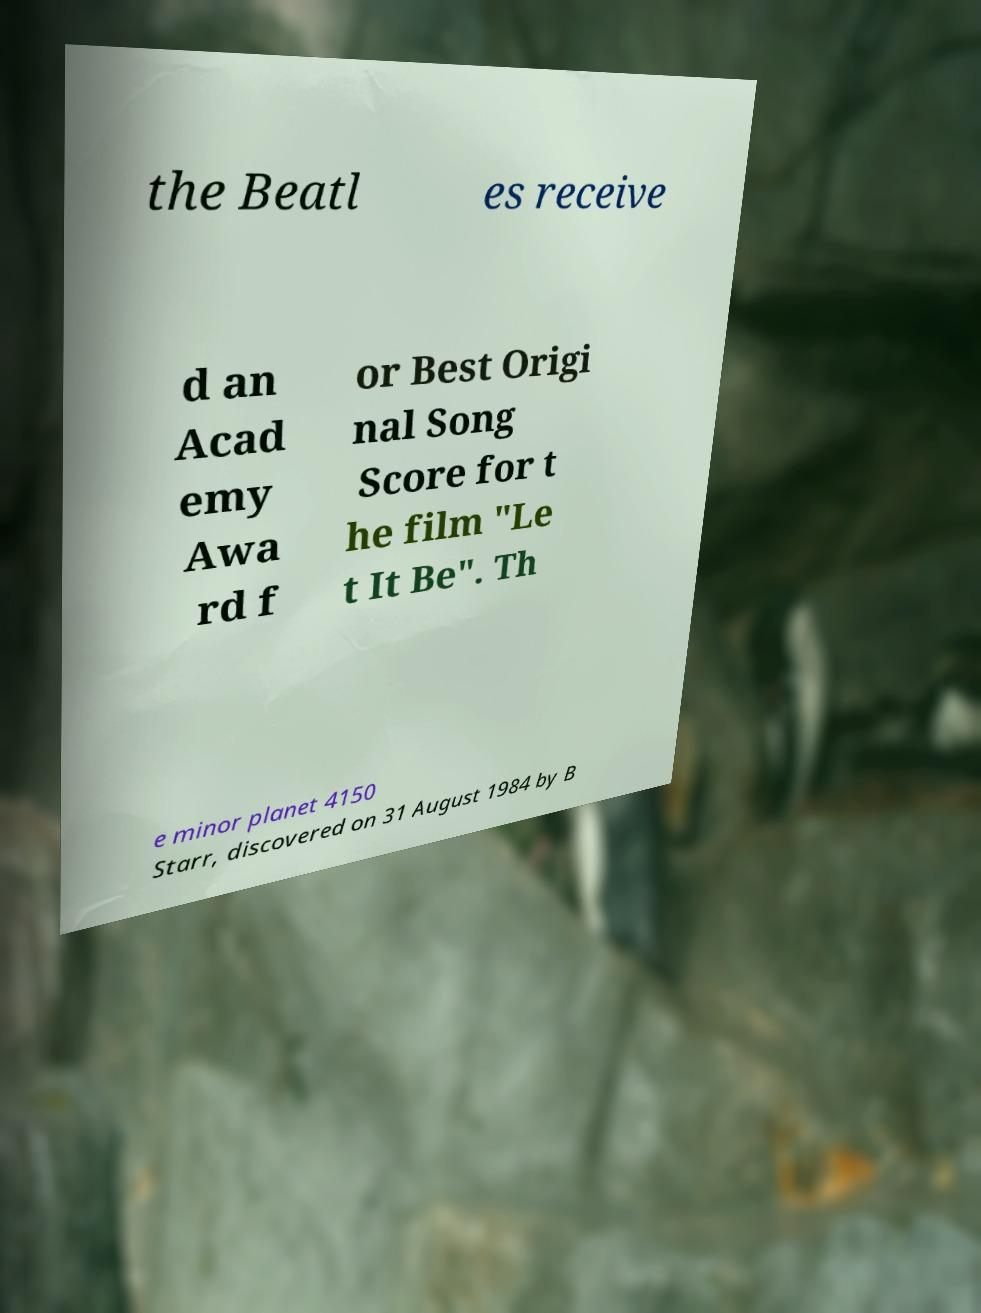Please identify and transcribe the text found in this image. the Beatl es receive d an Acad emy Awa rd f or Best Origi nal Song Score for t he film "Le t It Be". Th e minor planet 4150 Starr, discovered on 31 August 1984 by B 